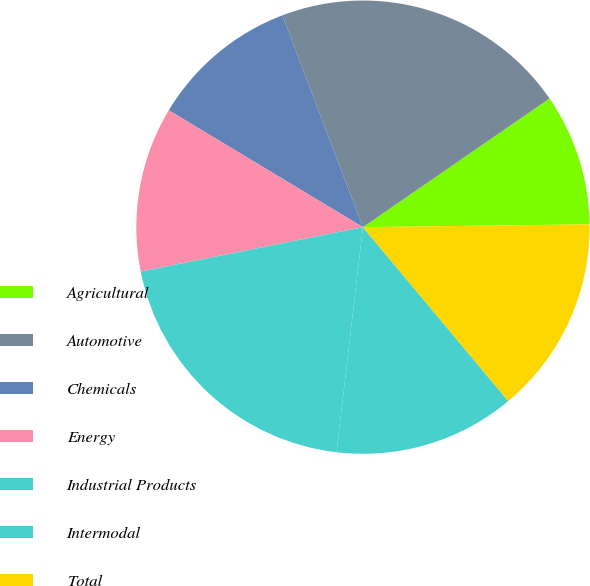Convert chart. <chart><loc_0><loc_0><loc_500><loc_500><pie_chart><fcel>Agricultural<fcel>Automotive<fcel>Chemicals<fcel>Energy<fcel>Industrial Products<fcel>Intermodal<fcel>Total<nl><fcel>9.41%<fcel>21.18%<fcel>10.59%<fcel>11.76%<fcel>20.0%<fcel>12.94%<fcel>14.12%<nl></chart> 